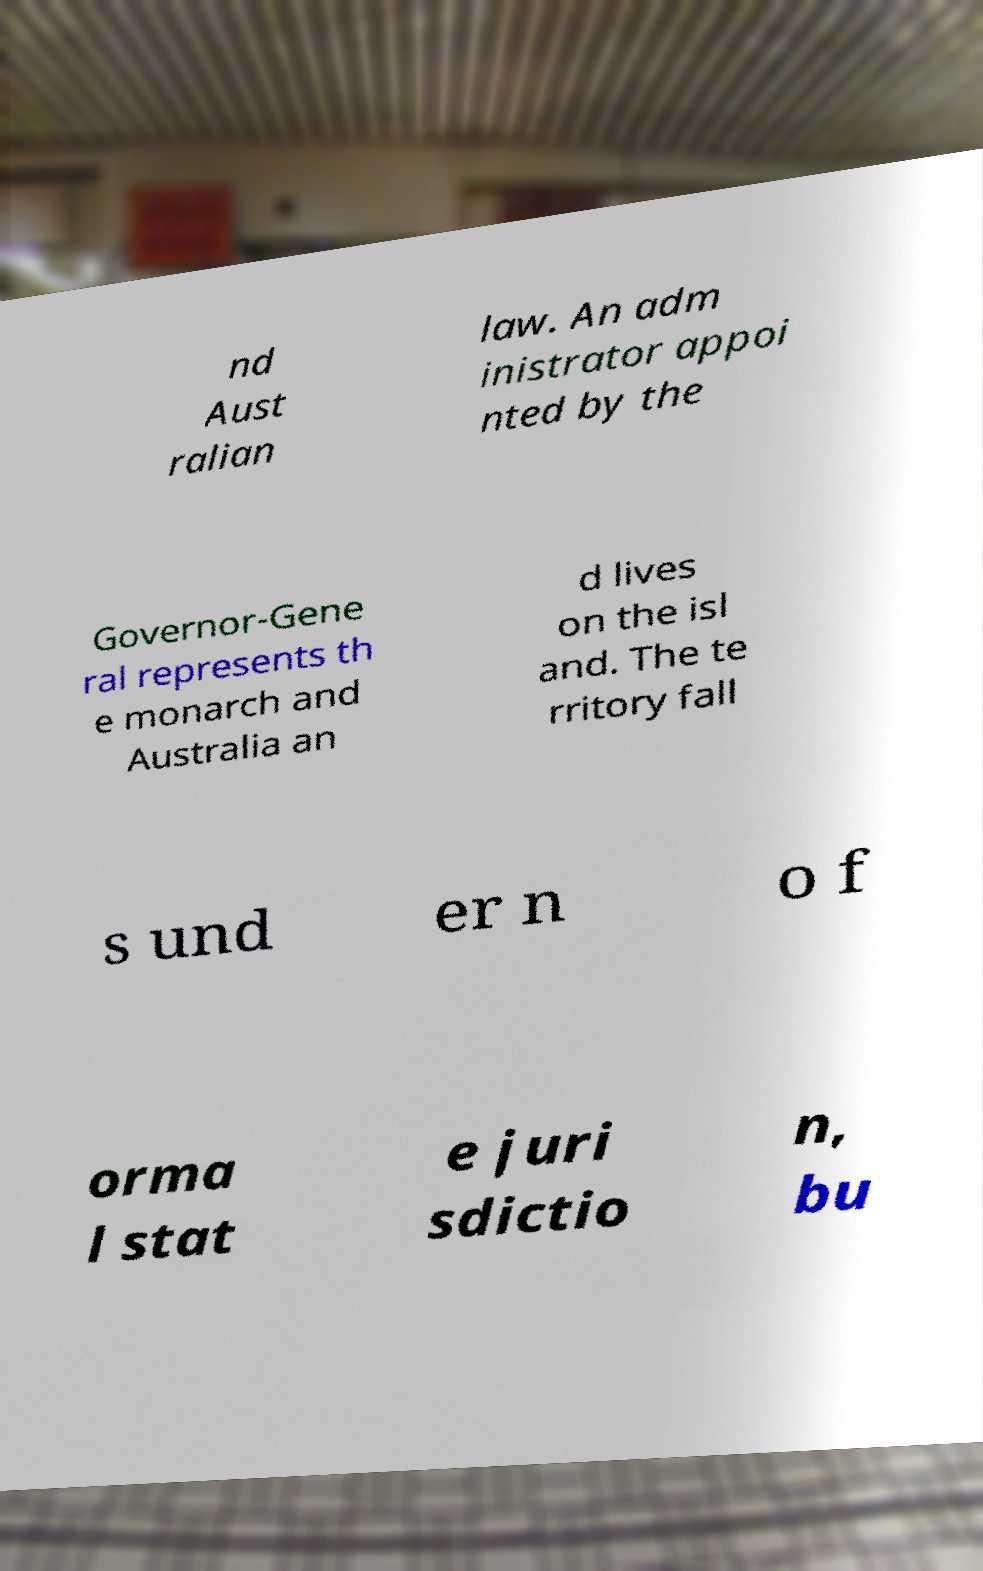There's text embedded in this image that I need extracted. Can you transcribe it verbatim? nd Aust ralian law. An adm inistrator appoi nted by the Governor-Gene ral represents th e monarch and Australia an d lives on the isl and. The te rritory fall s und er n o f orma l stat e juri sdictio n, bu 